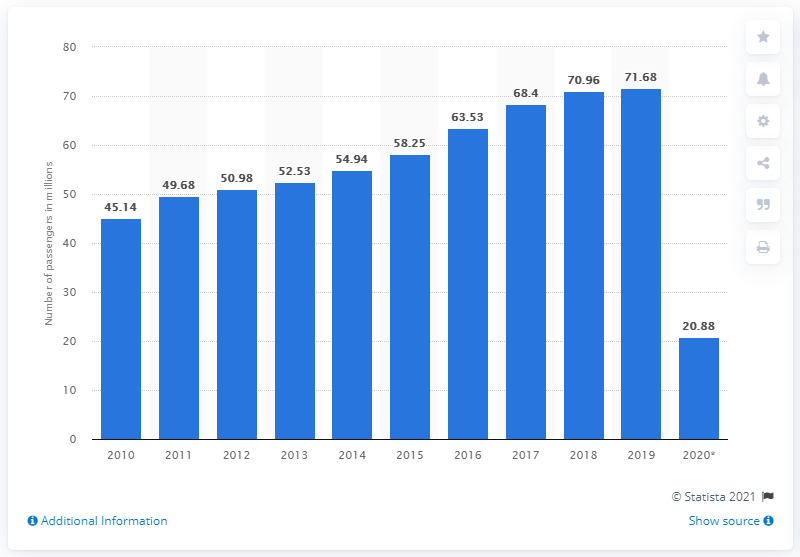Mention a couple of crucial points in this snapshot. In 2020, Amsterdam Airport Schiphol reported that a total of 20,880 passengers used the airport to fly to and from their destination. 